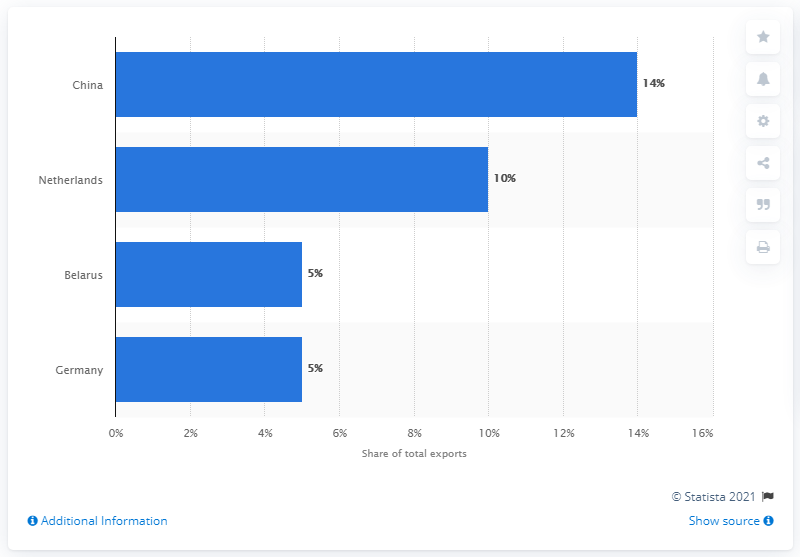Highlight a few significant elements in this photo. Russia's exports to China in 2019 made up 14% of its total exports. In 2019, China was the most significant export partner for Russia, accounting for a significant portion of the country's overall exports. 